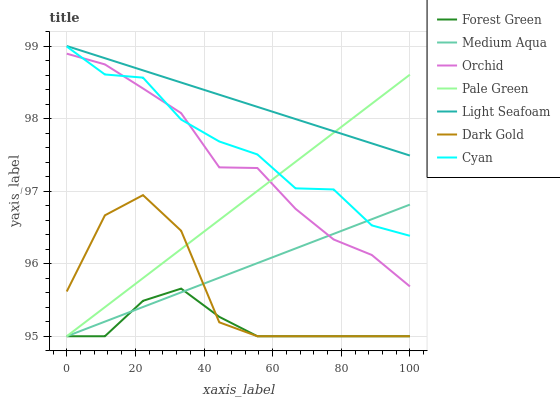Does Forest Green have the minimum area under the curve?
Answer yes or no. Yes. Does Light Seafoam have the maximum area under the curve?
Answer yes or no. Yes. Does Pale Green have the minimum area under the curve?
Answer yes or no. No. Does Pale Green have the maximum area under the curve?
Answer yes or no. No. Is Light Seafoam the smoothest?
Answer yes or no. Yes. Is Dark Gold the roughest?
Answer yes or no. Yes. Is Forest Green the smoothest?
Answer yes or no. No. Is Forest Green the roughest?
Answer yes or no. No. Does Dark Gold have the lowest value?
Answer yes or no. Yes. Does Cyan have the lowest value?
Answer yes or no. No. Does Light Seafoam have the highest value?
Answer yes or no. Yes. Does Pale Green have the highest value?
Answer yes or no. No. Is Cyan less than Light Seafoam?
Answer yes or no. Yes. Is Cyan greater than Dark Gold?
Answer yes or no. Yes. Does Forest Green intersect Medium Aqua?
Answer yes or no. Yes. Is Forest Green less than Medium Aqua?
Answer yes or no. No. Is Forest Green greater than Medium Aqua?
Answer yes or no. No. Does Cyan intersect Light Seafoam?
Answer yes or no. No. 